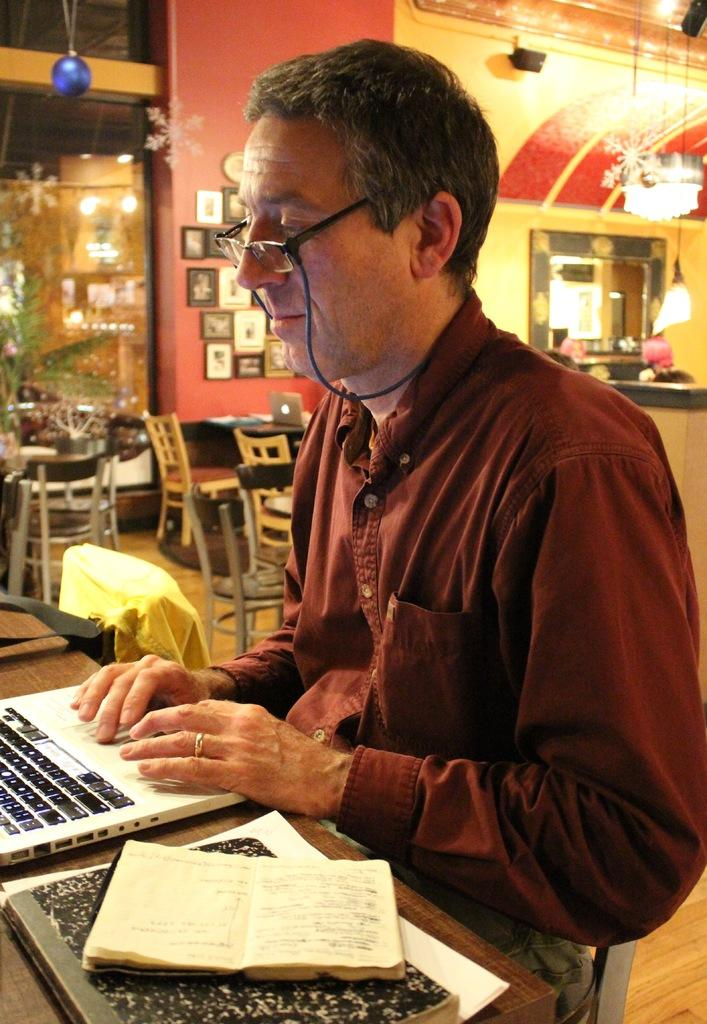Who is present in the image? There is a man in the image. What is the man doing in the image? The man is seated and working on a laptop. Where is the man located in the image? The setting is a store. What type of fork is the man using to express his opinion in the meeting? There is no fork or meeting present in the image; the man is working on a laptop in a store. 